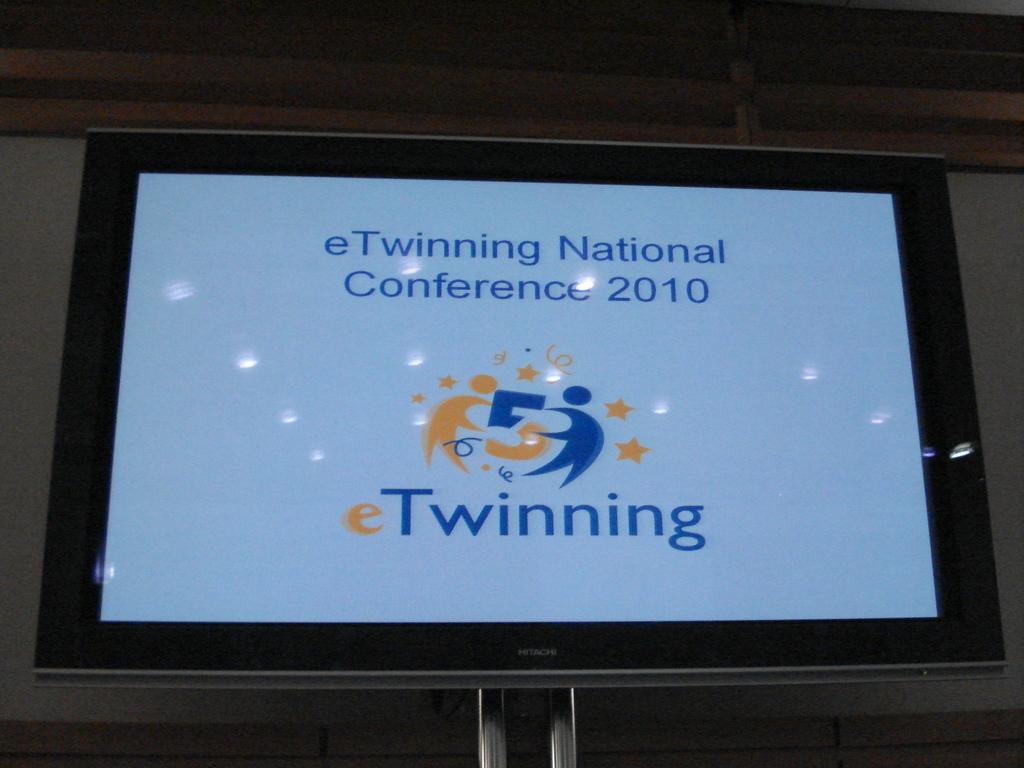What year is the conference?
Make the answer very short. 2010. What company put on this conference?
Your answer should be compact. Etwinning. 